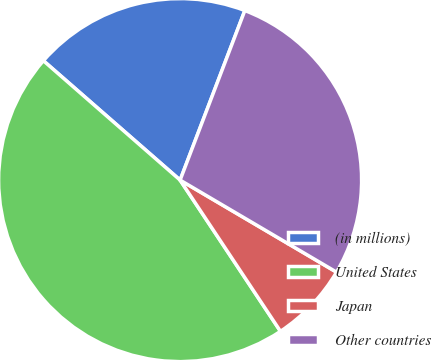Convert chart. <chart><loc_0><loc_0><loc_500><loc_500><pie_chart><fcel>(in millions)<fcel>United States<fcel>Japan<fcel>Other countries<nl><fcel>19.38%<fcel>45.75%<fcel>7.21%<fcel>27.66%<nl></chart> 